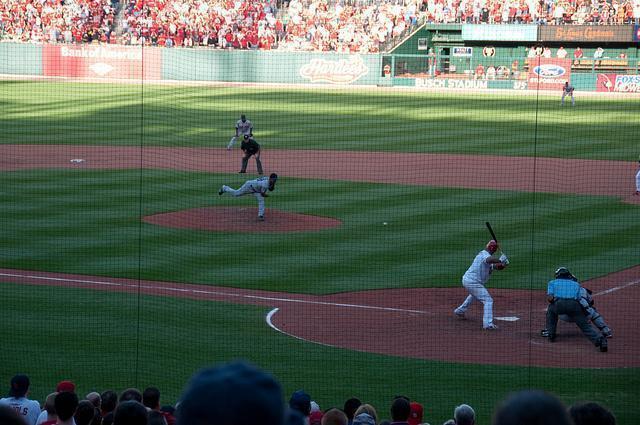What play is the best case scenario for the batter?
Answer the question by selecting the correct answer among the 4 following choices and explain your choice with a short sentence. The answer should be formatted with the following format: `Answer: choice
Rationale: rationale.`
Options: Home run, foul, walk, strike out. Answer: home run.
Rationale: The batter wants to successfully hit the ball and the most runs are scored by hitting the ball out of the park. 